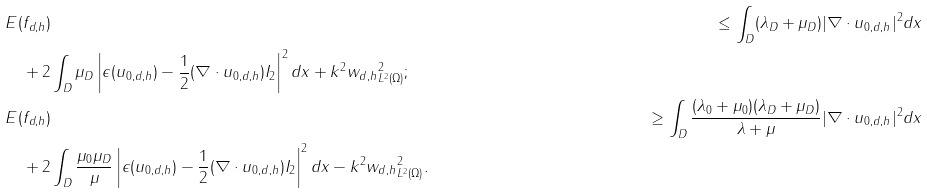<formula> <loc_0><loc_0><loc_500><loc_500>& E ( f _ { d , h } ) & \leq \int _ { D } ( \lambda _ { D } + \mu _ { D } ) | \nabla \cdot u _ { 0 , d , h } | ^ { 2 } d x \\ & \quad + 2 \int _ { D } \mu _ { D } \left | \epsilon ( u _ { 0 , d , h } ) - \frac { 1 } { 2 } ( \nabla \cdot u _ { 0 , d , h } ) I _ { 2 } \right | ^ { 2 } d x + k ^ { 2 } \| w _ { d , h } \| _ { L ^ { 2 } ( \Omega ) } ^ { 2 } ; \\ & E ( f _ { d , h } ) & \geq \int _ { D } \frac { ( \lambda _ { 0 } + \mu _ { 0 } ) ( \lambda _ { D } + \mu _ { D } ) } { \lambda + \mu } | \nabla \cdot u _ { 0 , d , h } | ^ { 2 } d x \\ & \quad + 2 \int _ { D } \frac { \mu _ { 0 } \mu _ { D } } { \mu } \left | \epsilon ( u _ { 0 , d , h } ) - \frac { 1 } { 2 } ( \nabla \cdot u _ { 0 , d , h } ) I _ { 2 } \right | ^ { 2 } d x - k ^ { 2 } \| w _ { d , h } \| _ { L ^ { 2 } ( \Omega ) } ^ { 2 } .</formula> 